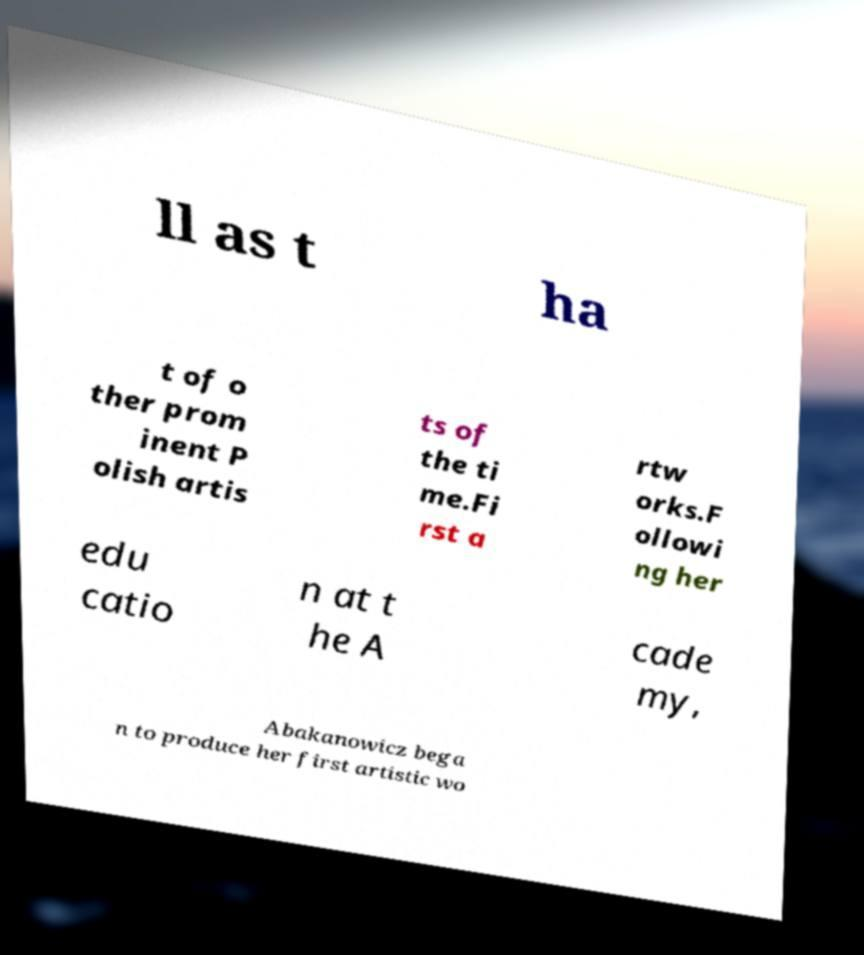Can you accurately transcribe the text from the provided image for me? ll as t ha t of o ther prom inent P olish artis ts of the ti me.Fi rst a rtw orks.F ollowi ng her edu catio n at t he A cade my, Abakanowicz bega n to produce her first artistic wo 